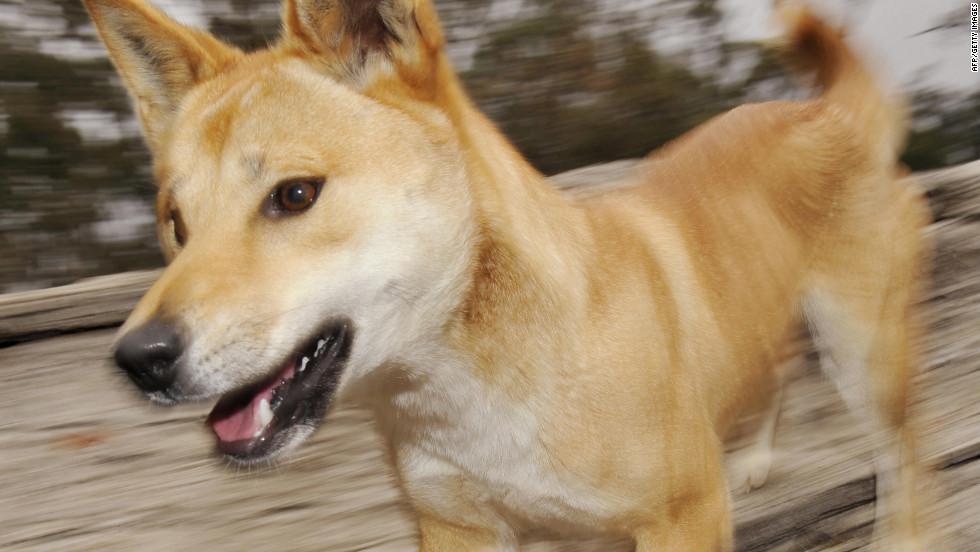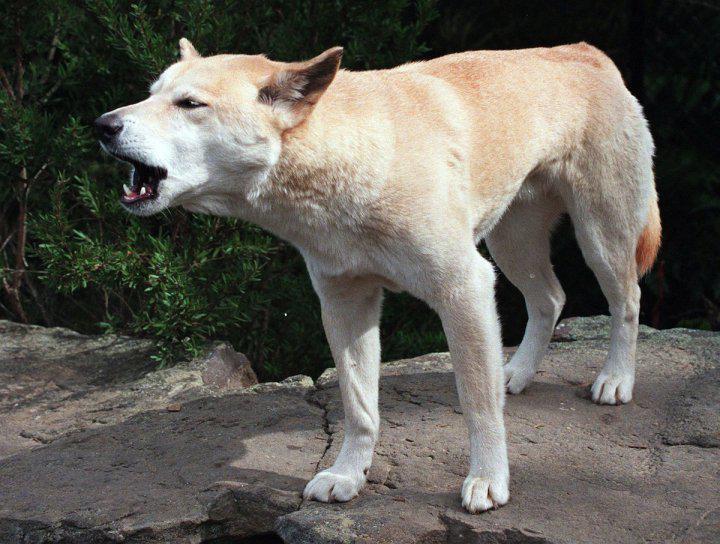The first image is the image on the left, the second image is the image on the right. For the images shown, is this caption "There are two dogs total on both images." true? Answer yes or no. Yes. 